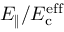<formula> <loc_0><loc_0><loc_500><loc_500>E _ { \| } / E _ { c } ^ { e f f }</formula> 